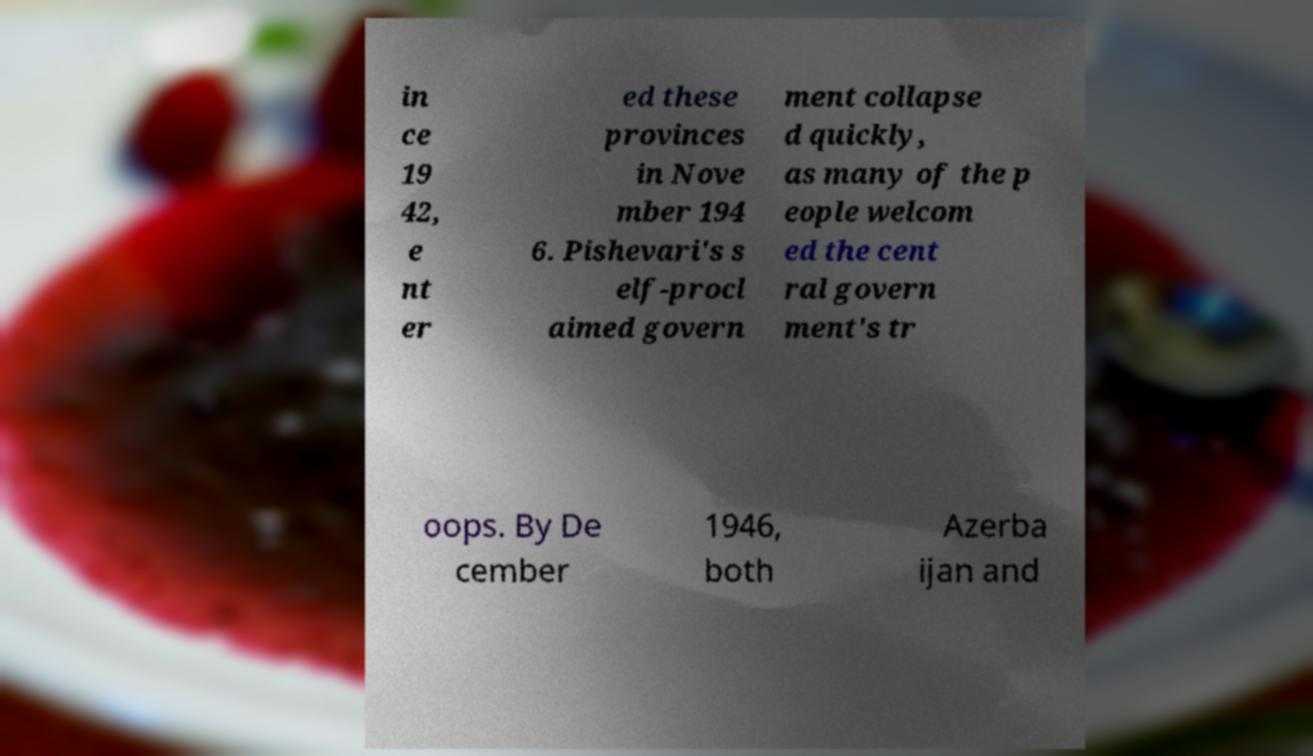There's text embedded in this image that I need extracted. Can you transcribe it verbatim? in ce 19 42, e nt er ed these provinces in Nove mber 194 6. Pishevari's s elf-procl aimed govern ment collapse d quickly, as many of the p eople welcom ed the cent ral govern ment's tr oops. By De cember 1946, both Azerba ijan and 